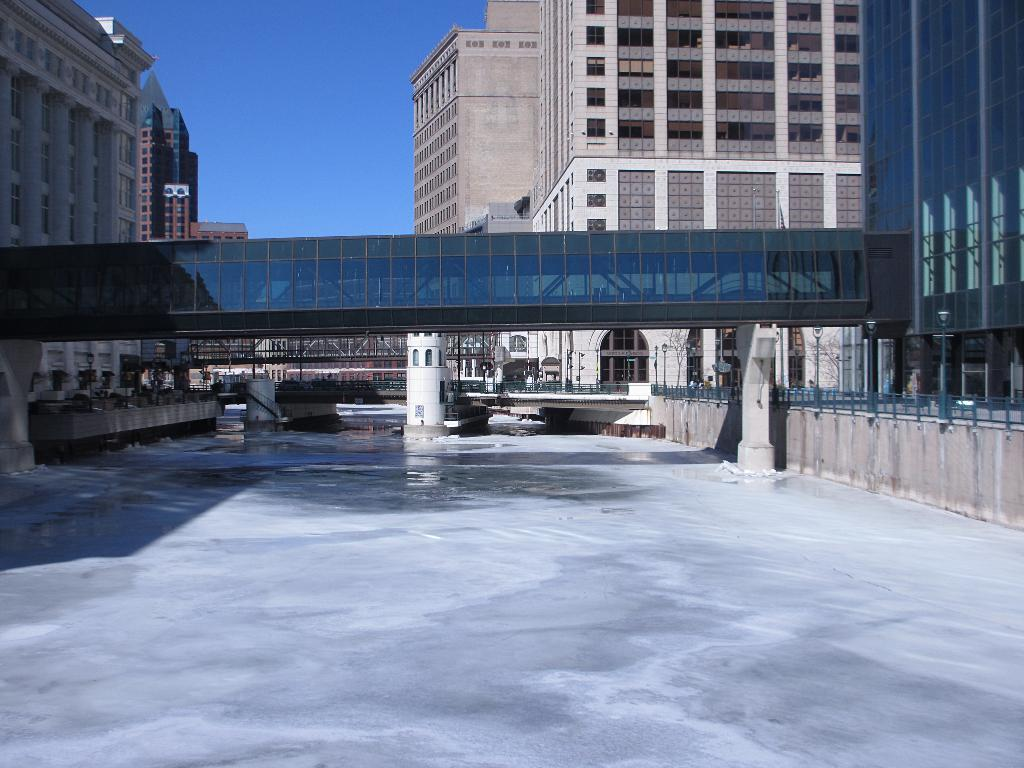What type of structures can be seen in the image? There are buildings with windows in the image. What architectural feature is present in the image? There is a bridge in the image. What material is used for the fencing in the image? The fencing in the image is made of metal. What part of the natural environment is visible in the image? The sky is visible in the image. Can you see a cook preparing food in the image? There is no cook or food preparation visible in the image. What type of tub is present in the image? There is no tub present in the image. 